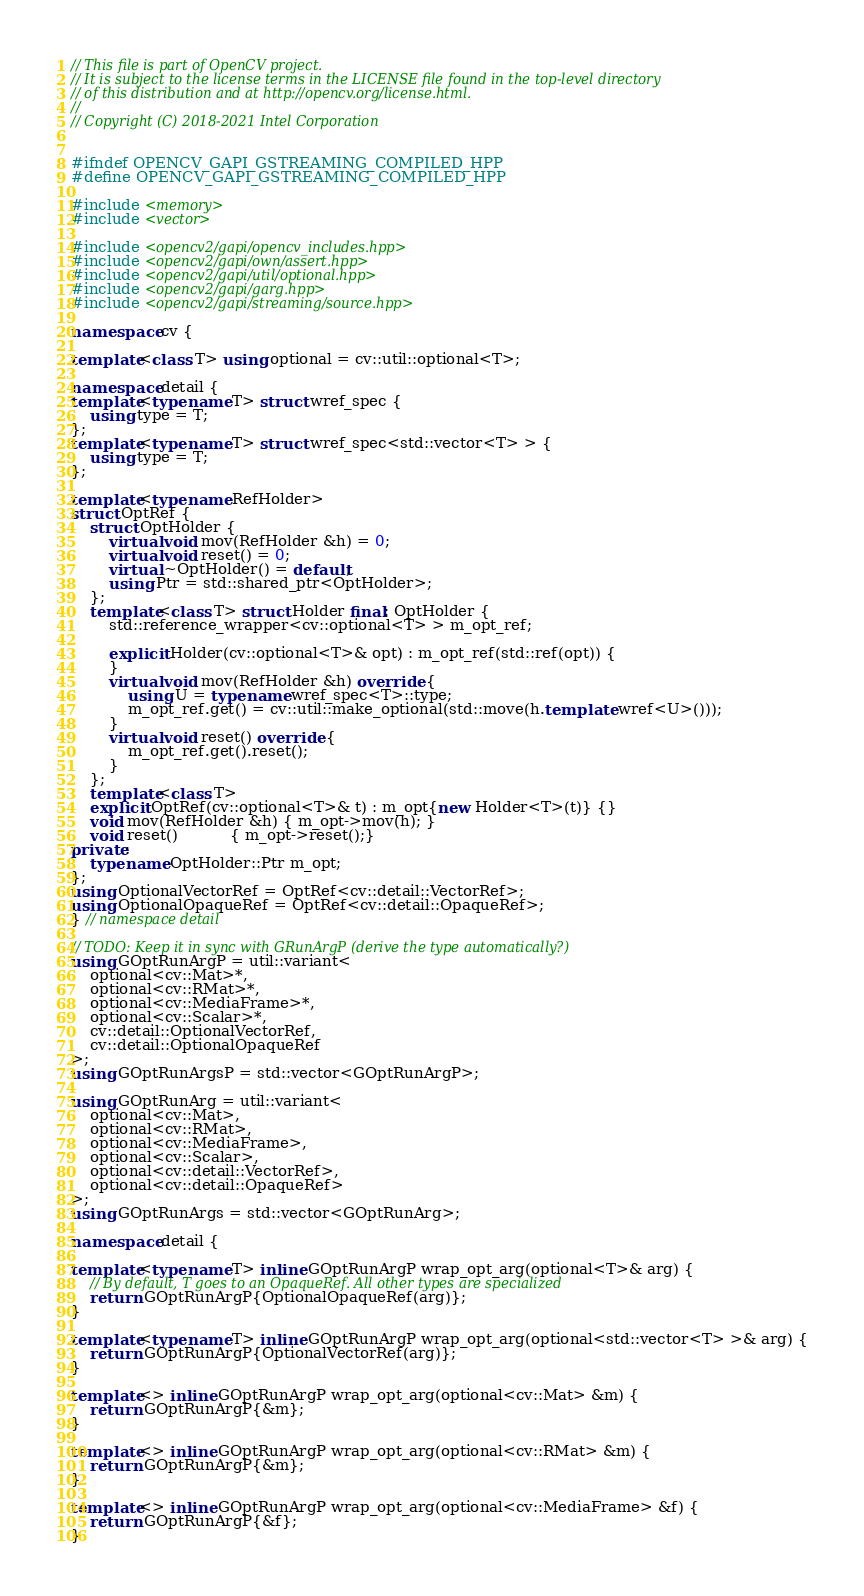<code> <loc_0><loc_0><loc_500><loc_500><_C++_>// This file is part of OpenCV project.
// It is subject to the license terms in the LICENSE file found in the top-level directory
// of this distribution and at http://opencv.org/license.html.
//
// Copyright (C) 2018-2021 Intel Corporation


#ifndef OPENCV_GAPI_GSTREAMING_COMPILED_HPP
#define OPENCV_GAPI_GSTREAMING_COMPILED_HPP

#include <memory>
#include <vector>

#include <opencv2/gapi/opencv_includes.hpp>
#include <opencv2/gapi/own/assert.hpp>
#include <opencv2/gapi/util/optional.hpp>
#include <opencv2/gapi/garg.hpp>
#include <opencv2/gapi/streaming/source.hpp>

namespace cv {

template<class T> using optional = cv::util::optional<T>;

namespace detail {
template<typename T> struct wref_spec {
    using type = T;
};
template<typename T> struct wref_spec<std::vector<T> > {
    using type = T;
};

template<typename RefHolder>
struct OptRef {
    struct OptHolder {
        virtual void mov(RefHolder &h) = 0;
        virtual void reset() = 0;
        virtual ~OptHolder() = default;
        using Ptr = std::shared_ptr<OptHolder>;
    };
    template<class T> struct Holder final: OptHolder {
        std::reference_wrapper<cv::optional<T> > m_opt_ref;

        explicit Holder(cv::optional<T>& opt) : m_opt_ref(std::ref(opt)) {
        }
        virtual void mov(RefHolder &h) override {
            using U = typename wref_spec<T>::type;
            m_opt_ref.get() = cv::util::make_optional(std::move(h.template wref<U>()));
        }
        virtual void reset() override {
            m_opt_ref.get().reset();
        }
    };
    template<class T>
    explicit OptRef(cv::optional<T>& t) : m_opt{new Holder<T>(t)} {}
    void mov(RefHolder &h) { m_opt->mov(h); }
    void reset()           { m_opt->reset();}
private:
    typename OptHolder::Ptr m_opt;
};
using OptionalVectorRef = OptRef<cv::detail::VectorRef>;
using OptionalOpaqueRef = OptRef<cv::detail::OpaqueRef>;
} // namespace detail

// TODO: Keep it in sync with GRunArgP (derive the type automatically?)
using GOptRunArgP = util::variant<
    optional<cv::Mat>*,
    optional<cv::RMat>*,
    optional<cv::MediaFrame>*,
    optional<cv::Scalar>*,
    cv::detail::OptionalVectorRef,
    cv::detail::OptionalOpaqueRef
>;
using GOptRunArgsP = std::vector<GOptRunArgP>;

using GOptRunArg = util::variant<
    optional<cv::Mat>,
    optional<cv::RMat>,
    optional<cv::MediaFrame>,
    optional<cv::Scalar>,
    optional<cv::detail::VectorRef>,
    optional<cv::detail::OpaqueRef>
>;
using GOptRunArgs = std::vector<GOptRunArg>;

namespace detail {

template<typename T> inline GOptRunArgP wrap_opt_arg(optional<T>& arg) {
    // By default, T goes to an OpaqueRef. All other types are specialized
    return GOptRunArgP{OptionalOpaqueRef(arg)};
}

template<typename T> inline GOptRunArgP wrap_opt_arg(optional<std::vector<T> >& arg) {
    return GOptRunArgP{OptionalVectorRef(arg)};
}

template<> inline GOptRunArgP wrap_opt_arg(optional<cv::Mat> &m) {
    return GOptRunArgP{&m};
}

template<> inline GOptRunArgP wrap_opt_arg(optional<cv::RMat> &m) {
    return GOptRunArgP{&m};
}

template<> inline GOptRunArgP wrap_opt_arg(optional<cv::MediaFrame> &f) {
    return GOptRunArgP{&f};
}
</code> 